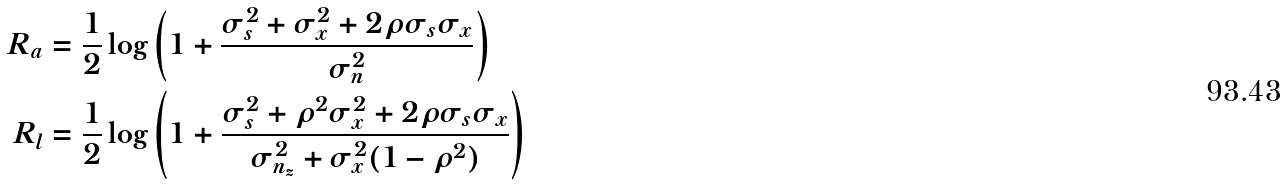Convert formula to latex. <formula><loc_0><loc_0><loc_500><loc_500>R _ { a } & = \frac { 1 } { 2 } \log \left ( 1 + \frac { \sigma _ { s } ^ { 2 } + \sigma _ { x } ^ { 2 } + 2 \rho \sigma _ { s } \sigma _ { x } } { \sigma _ { n } ^ { 2 } } \right ) \\ R _ { l } & = \frac { 1 } { 2 } \log \left ( 1 + \frac { \sigma _ { s } ^ { 2 } + \rho ^ { 2 } \sigma _ { x } ^ { 2 } + 2 \rho \sigma _ { s } \sigma _ { x } } { \sigma _ { n _ { z } } ^ { 2 } + \sigma _ { x } ^ { 2 } ( 1 - \rho ^ { 2 } ) } \right )</formula> 